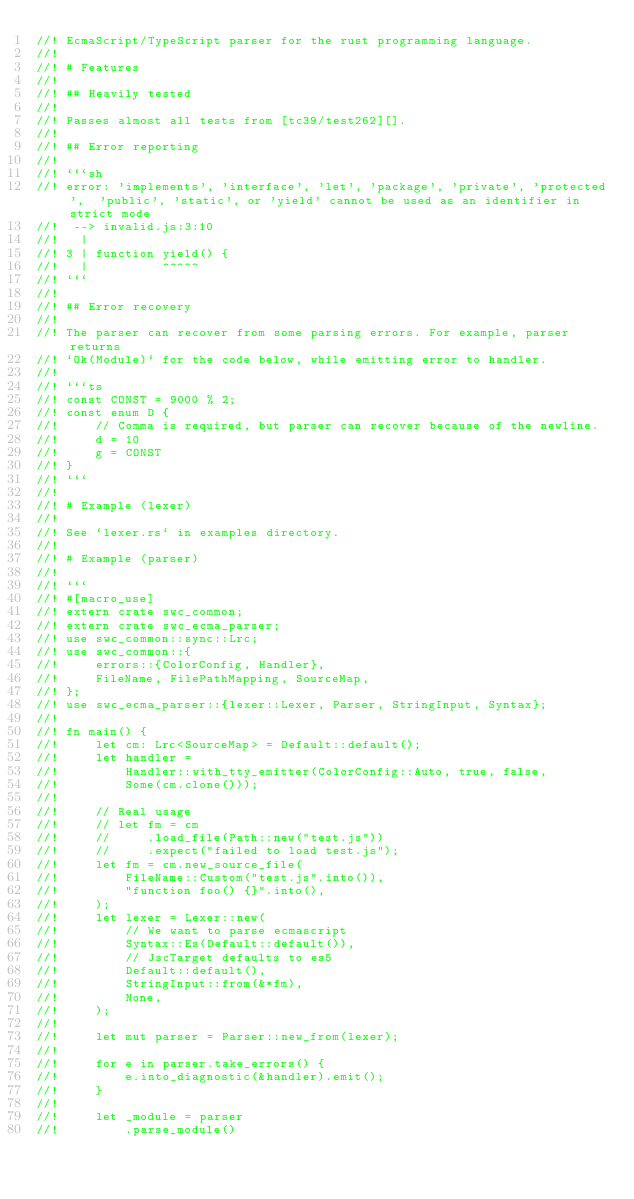<code> <loc_0><loc_0><loc_500><loc_500><_Rust_>//! EcmaScript/TypeScript parser for the rust programming language.
//!
//! # Features
//!
//! ## Heavily tested
//!
//! Passes almost all tests from [tc39/test262][].
//!
//! ## Error reporting
//!
//! ```sh
//! error: 'implements', 'interface', 'let', 'package', 'private', 'protected',  'public', 'static', or 'yield' cannot be used as an identifier in strict mode
//!  --> invalid.js:3:10
//!   |
//! 3 | function yield() {
//!   |          ^^^^^
//! ```
//!
//! ## Error recovery
//!
//! The parser can recover from some parsing errors. For example, parser returns
//! `Ok(Module)` for the code below, while emitting error to handler.
//!
//! ```ts
//! const CONST = 9000 % 2;
//! const enum D {
//!     // Comma is required, but parser can recover because of the newline.
//!     d = 10
//!     g = CONST
//! }
//! ```
//!
//! # Example (lexer)
//!
//! See `lexer.rs` in examples directory.
//!
//! # Example (parser)
//!
//! ```
//! #[macro_use]
//! extern crate swc_common;
//! extern crate swc_ecma_parser;
//! use swc_common::sync::Lrc;
//! use swc_common::{
//!     errors::{ColorConfig, Handler},
//!     FileName, FilePathMapping, SourceMap,
//! };
//! use swc_ecma_parser::{lexer::Lexer, Parser, StringInput, Syntax};
//!
//! fn main() {
//!     let cm: Lrc<SourceMap> = Default::default();
//!     let handler =
//!         Handler::with_tty_emitter(ColorConfig::Auto, true, false,
//!         Some(cm.clone()));
//!
//!     // Real usage
//!     // let fm = cm
//!     //     .load_file(Path::new("test.js"))
//!     //     .expect("failed to load test.js");
//!     let fm = cm.new_source_file(
//!         FileName::Custom("test.js".into()),
//!         "function foo() {}".into(),
//!     );
//!     let lexer = Lexer::new(
//!         // We want to parse ecmascript
//!         Syntax::Es(Default::default()),
//!         // JscTarget defaults to es5
//!         Default::default(),
//!         StringInput::from(&*fm),
//!         None,
//!     );
//!
//!     let mut parser = Parser::new_from(lexer);
//!
//!     for e in parser.take_errors() {
//!         e.into_diagnostic(&handler).emit();
//!     }
//!
//!     let _module = parser
//!         .parse_module()</code> 